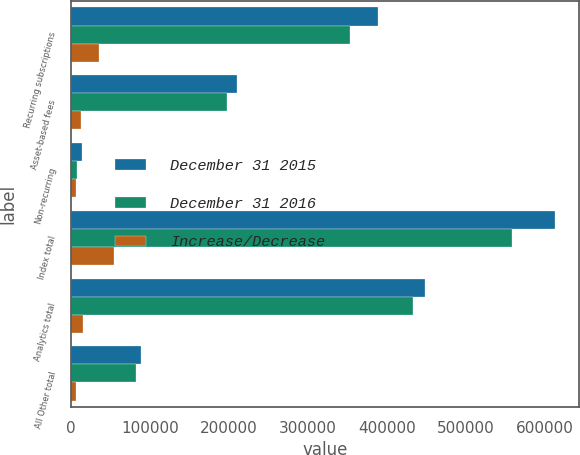Convert chart to OTSL. <chart><loc_0><loc_0><loc_500><loc_500><stacked_bar_chart><ecel><fcel>Recurring subscriptions<fcel>Asset-based fees<fcel>Non-recurring<fcel>Index total<fcel>Analytics total<fcel>All Other total<nl><fcel>December 31 2015<fcel>389348<fcel>210229<fcel>13974<fcel>613551<fcel>448353<fcel>88765<nl><fcel>December 31 2016<fcel>353136<fcel>197974<fcel>7854<fcel>558964<fcel>433424<fcel>82625<nl><fcel>Increase/Decrease<fcel>36212<fcel>12255<fcel>6120<fcel>54587<fcel>14929<fcel>6140<nl></chart> 